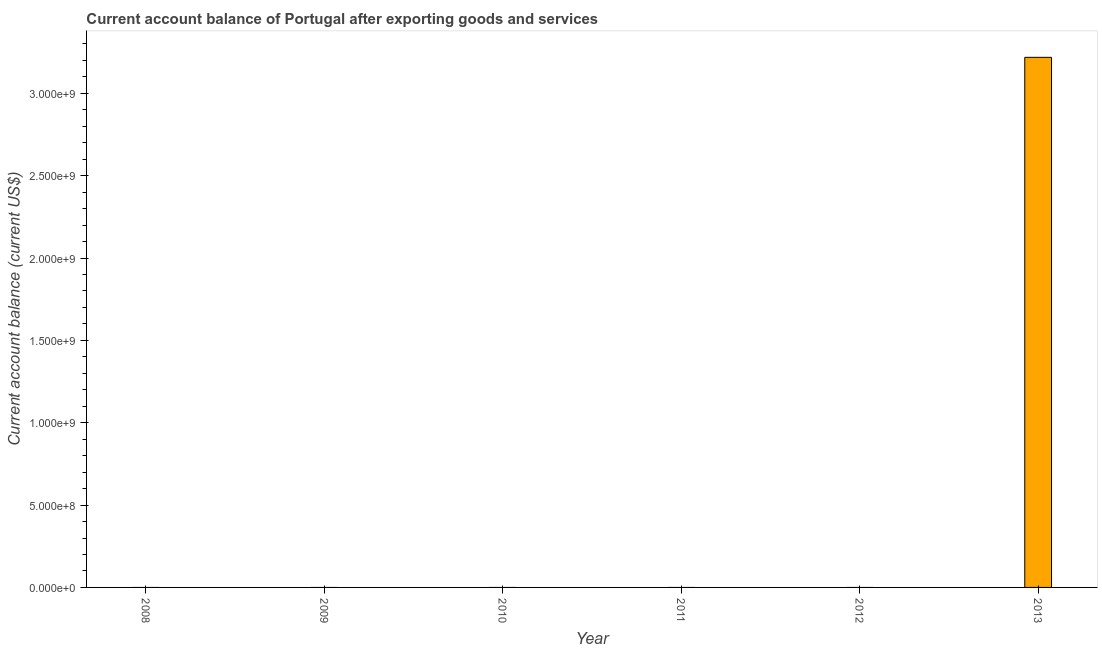What is the title of the graph?
Ensure brevity in your answer.  Current account balance of Portugal after exporting goods and services. What is the label or title of the X-axis?
Provide a short and direct response. Year. What is the label or title of the Y-axis?
Your response must be concise. Current account balance (current US$). What is the current account balance in 2010?
Your answer should be compact. 0. Across all years, what is the maximum current account balance?
Offer a very short reply. 3.22e+09. Across all years, what is the minimum current account balance?
Offer a terse response. 0. In which year was the current account balance maximum?
Offer a very short reply. 2013. What is the sum of the current account balance?
Keep it short and to the point. 3.22e+09. What is the average current account balance per year?
Keep it short and to the point. 5.36e+08. In how many years, is the current account balance greater than 400000000 US$?
Ensure brevity in your answer.  1. What is the difference between the highest and the lowest current account balance?
Keep it short and to the point. 3.22e+09. How many bars are there?
Ensure brevity in your answer.  1. What is the Current account balance (current US$) of 2008?
Your response must be concise. 0. What is the Current account balance (current US$) of 2009?
Offer a terse response. 0. What is the Current account balance (current US$) in 2013?
Offer a terse response. 3.22e+09. 